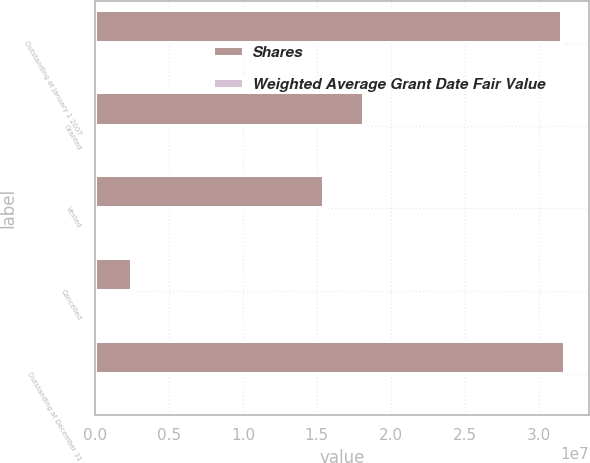Convert chart. <chart><loc_0><loc_0><loc_500><loc_500><stacked_bar_chart><ecel><fcel>Outstanding at January 1 2007<fcel>Granted<fcel>Vested<fcel>Cancelled<fcel>Outstanding at December 31<nl><fcel>Shares<fcel>3.15893e+07<fcel>1.82131e+07<fcel>1.55e+07<fcel>2.48071e+06<fcel>3.18217e+07<nl><fcel>Weighted Average Grant Date Fair Value<fcel>43.85<fcel>53.82<fcel>44.53<fcel>49.26<fcel>48.8<nl></chart> 